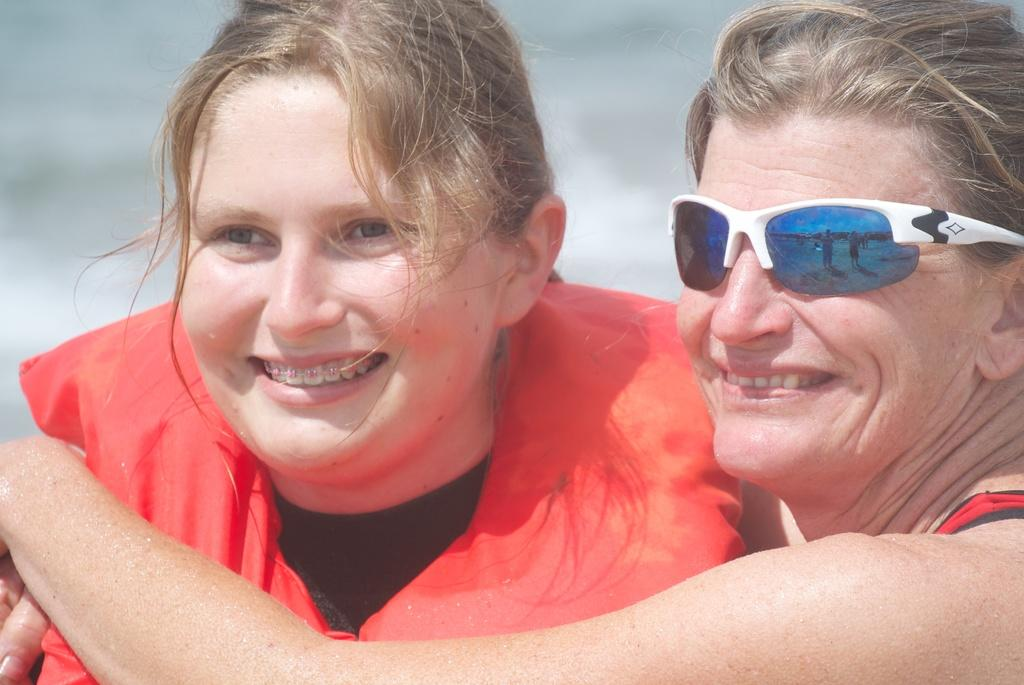How many women are in the image? There are women in the image. Can you describe the appearance of one of the women? One woman is wearing sunglasses. What can be said about the background of the image? The background of the image is blurry. Is there an expert in the middle of the image? There is no mention of an expert or any specific person in the middle of the image. 